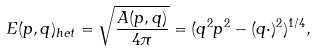Convert formula to latex. <formula><loc_0><loc_0><loc_500><loc_500>E ( p , q ) _ { h e t } = \sqrt { \frac { A ( p , q ) } { 4 \pi } } = ( q ^ { 2 } p ^ { 2 } - ( q \cdot ) ^ { 2 } ) ^ { 1 / 4 } ,</formula> 